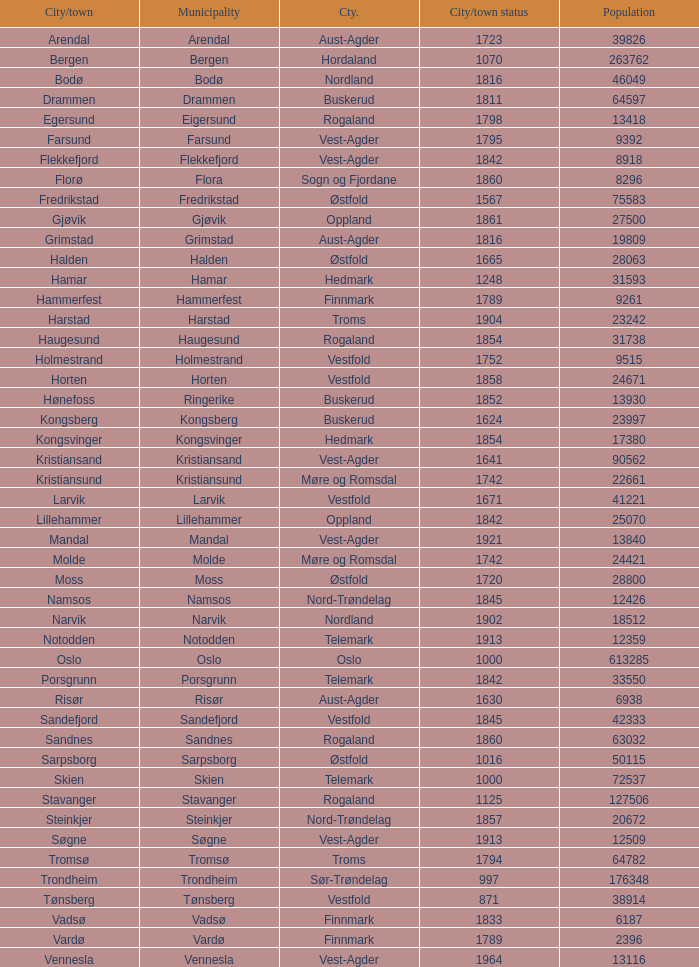What are the cities/towns located in the municipality of Horten? Horten. 